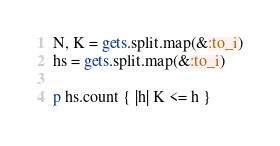Convert code to text. <code><loc_0><loc_0><loc_500><loc_500><_Ruby_>N, K = gets.split.map(&:to_i)
hs = gets.split.map(&:to_i)

p hs.count { |h| K <= h }
</code> 